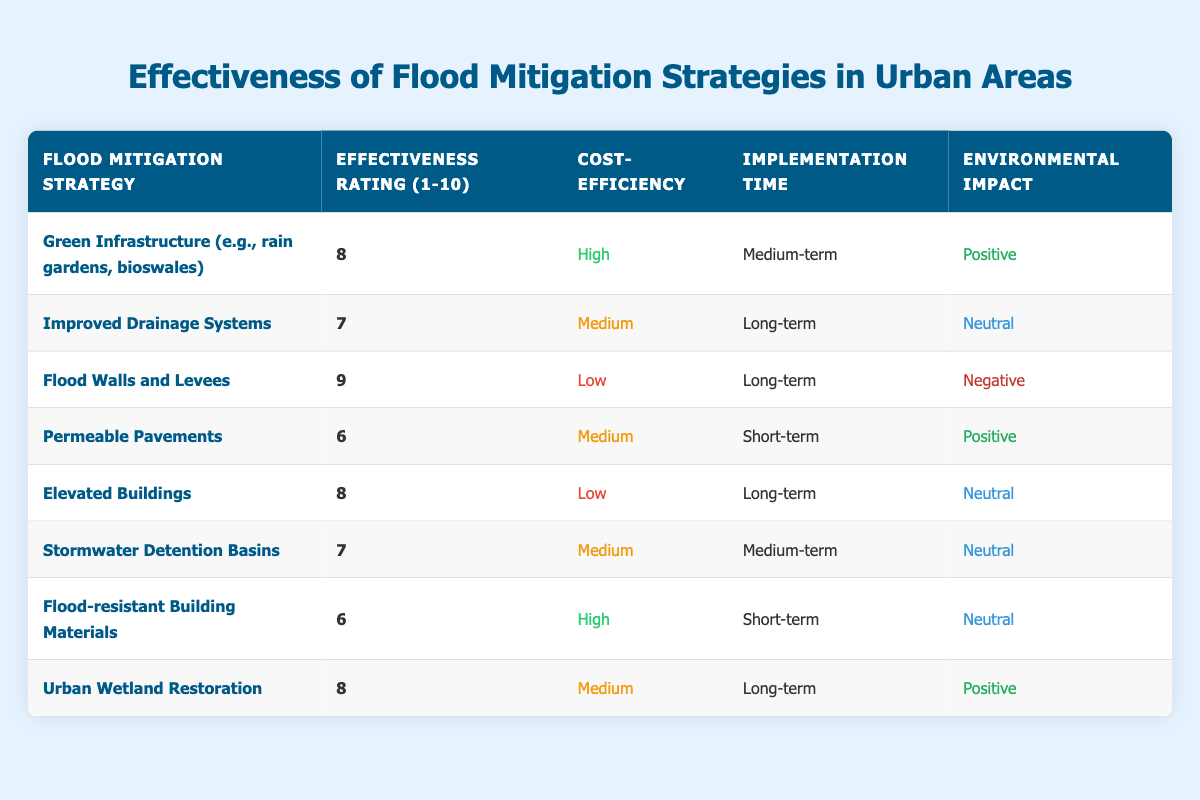What is the effectiveness rating of Flood Walls and Levees? The table shows that the effectiveness rating for Flood Walls and Levees is 9. This information is found directly in the corresponding row under the "Effectiveness Rating (1-10)" column.
Answer: 9 Which flood mitigation strategies have a positive environmental impact? From the table, the strategies with a positive environmental impact are Green Infrastructure, Permeable Pavements, Urban Wetland Restoration. These can be identified by checking the "Environmental Impact" column for "Positive."
Answer: Green Infrastructure, Permeable Pavements, Urban Wetland Restoration What is the average effectiveness rating of all flood mitigation strategies? The effectiveness ratings are 8, 7, 9, 6, 8, 7, 6, and 8. To find the average, we sum these ratings (8 + 7 + 9 + 6 + 8 + 7 + 6 + 8 = 59) and divide by the number of strategies (8), giving us an average of 59 / 8 = 7.375.
Answer: 7.375 Is the cost-efficiency of Elevated Buildings high? The table indicates that Elevated Buildings have a low cost-efficiency. By looking under the "Cost-Efficiency" column for Elevated Buildings, it is clear that the answer is no.
Answer: No Which flood mitigation strategies have a long implementation time? The table lists several strategies with Long-term implementation times: Improved Drainage Systems, Flood Walls and Levees, Elevated Buildings, and Urban Wetland Restoration. This is found by checking the "Implementation Time" column for "Long-term."
Answer: Improved Drainage Systems, Flood Walls and Levees, Elevated Buildings, Urban Wetland Restoration How many strategies have a medium cost-efficiency? By scanning the "Cost-Efficiency" column, we can count that there are three strategies marked as Medium: Improved Drainage Systems, Stormwater Detention Basins, and Permeable Pavements.
Answer: 3 Which strategy has the highest effectiveness rating and what is its cost-efficiency? Flood Walls and Levees have the highest effectiveness rating of 9, as indicated in the table, with a corresponding cost-efficiency of low. First, we check all effectiveness ratings, identify the maximum rating of 9, and then confirm its associated cost-efficiency.
Answer: Flood Walls and Levees; Low Are there any strategies with a short-term implementation time that also have a negative environmental impact? The analysis of the table shows that there are no strategies categorized with both short-term implementation and a negative environmental impact. The only short-term implementations are Permeable Pavements and Flood-resistant Building Materials, which are positive and neutral, respectively.
Answer: No 